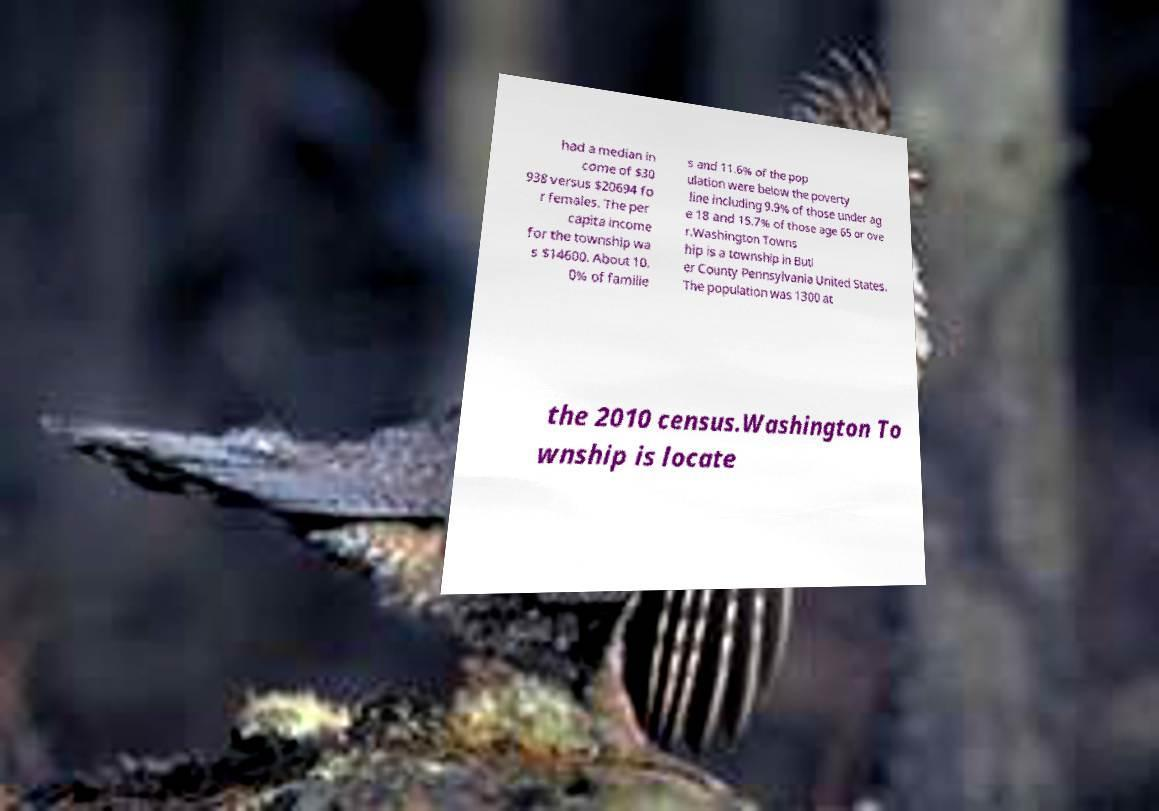Could you extract and type out the text from this image? had a median in come of $30 938 versus $20694 fo r females. The per capita income for the township wa s $14600. About 10. 0% of familie s and 11.6% of the pop ulation were below the poverty line including 9.9% of those under ag e 18 and 15.7% of those age 65 or ove r.Washington Towns hip is a township in Butl er County Pennsylvania United States. The population was 1300 at the 2010 census.Washington To wnship is locate 